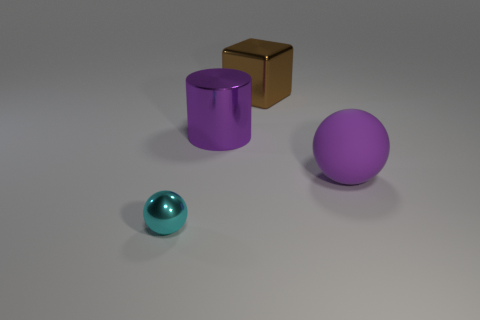What is the material of the cylinder that is the same size as the rubber thing?
Give a very brief answer. Metal. What number of other objects are the same material as the small sphere?
Your answer should be very brief. 2. What is the shape of the big purple object that is behind the sphere to the right of the large brown metallic object?
Your answer should be very brief. Cylinder. How many things are either big gray cylinders or balls that are to the left of the big matte sphere?
Give a very brief answer. 1. What number of other objects are there of the same color as the metal cylinder?
Give a very brief answer. 1. What number of yellow things are big metal cylinders or big balls?
Give a very brief answer. 0. There is a big purple thing on the left side of the big metal object to the right of the big purple cylinder; is there a cylinder that is on the left side of it?
Your answer should be compact. No. Are there any other things that have the same size as the cyan shiny sphere?
Your answer should be very brief. No. Do the big block and the shiny cylinder have the same color?
Give a very brief answer. No. What is the color of the sphere that is to the left of the ball that is behind the metallic sphere?
Your answer should be compact. Cyan. 